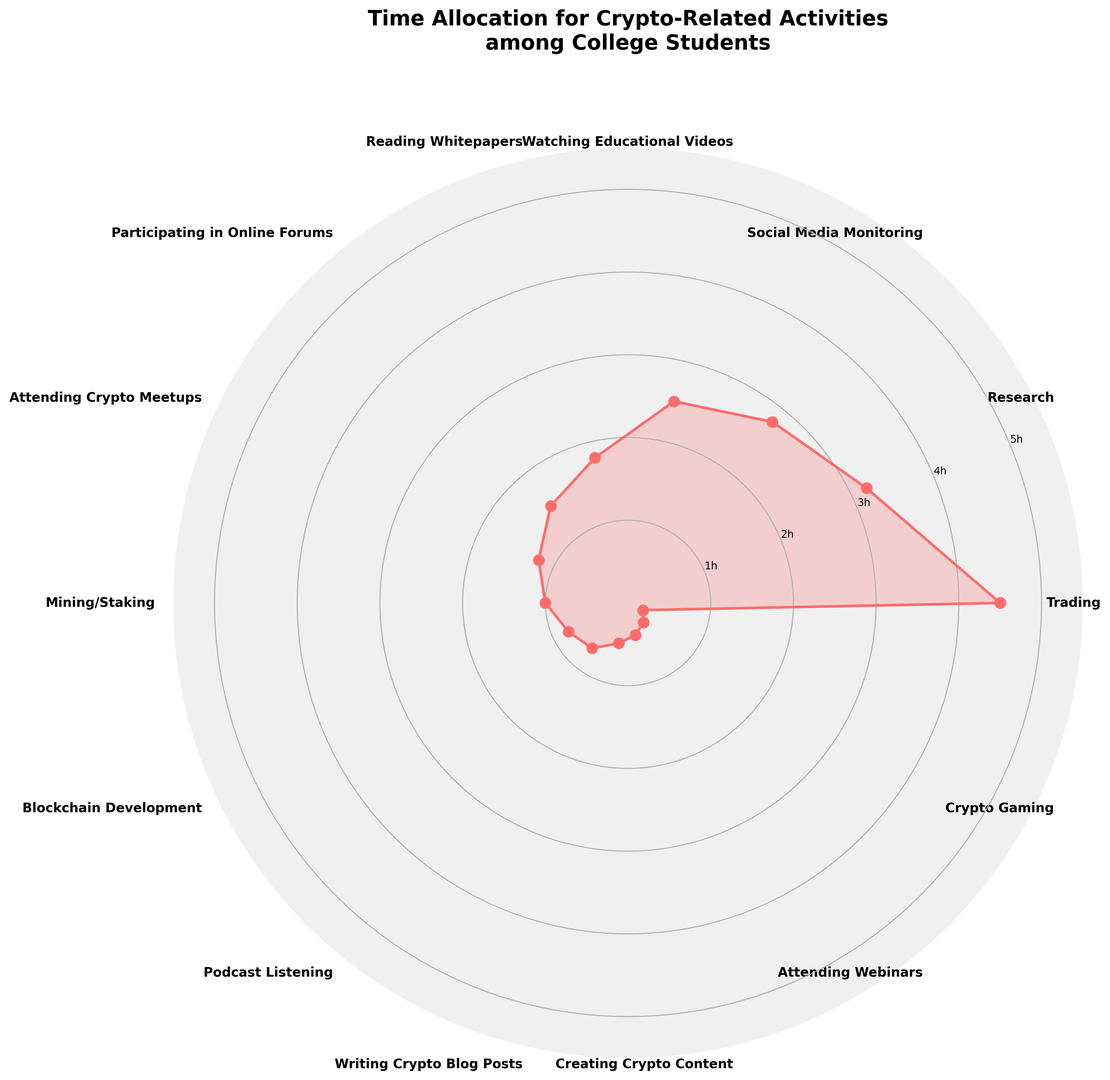What activity do college students spend the most hours on? By looking at the outermost data point on the rose chart, we observe that the activity 'Trading' peaks at 4.5 hours, which is the highest among all activities.
Answer: Trading What is the difference in hours spent between 'Research' and 'Watching Educational Videos'? To find the difference, subtract the hours spent on 'Watching Educational Videos' (2.5) from the hours spent on 'Research' (3.2). The difference is 3.2 - 2.5 = 0.7 hours.
Answer: 0.7 hours How many hours in total do students spend on the top three activities? The top three activities by hours are 'Trading' (4.5), 'Research' (3.2), and 'Social Media Monitoring' (2.8). The total sum is 4.5 + 3.2 + 2.8 = 10.5 hours.
Answer: 10.5 hours Which activity has the least time allocation? By observing the innermost point on the rose chart, we see that 'Crypto Gaming' is at 0.2 hours, which is the lowest among all activities.
Answer: Crypto Gaming How does the time spent on 'Mining/Staking' compare to the time spent on 'Blockchain Development'? 'Mining/Staking' is allocated 1.0 hours, whereas 'Blockchain Development' is allocated 0.8 hours. Therefore, 'Mining/Staking' has 0.2 more hours.
Answer: Mining/Staking has 0.2 more hours Which activities have time allocations within the 1.0 to 1.5-hour range? The activities with time allocations between 1.0 and 1.5 hours are 'Participating in Online Forums' (1.5 hours), 'Attending Crypto Meetups' (1.2 hours), and 'Mining/Staking' (1.0 hours).
Answer: Participating in Online Forums, Attending Crypto Meetups, Mining/Staking Are there more activities with time allocations below 0.5 hours or above 2.5 hours? Activities below 0.5 hours are 'Podcast Listening' (0.7), 'Writing Crypto Blog Posts' (0.5), 'Creating Crypto Content' (0.4), 'Attending Webinars' (0.3), 'Crypto Gaming' (0.2). Counts to 5 activities. Activities above 2.5 hours are 'Trading' (4.5), 'Research' (3.2), 'Social Media Monitoring' (2.8). Counts to 3 activities.
Answer: More activities below 0.5 hours What is the average amount of time spent on 'Watching Educational Videos', 'Reading Whitepapers', and 'Podcast Listening'? Sum the hours spent on these activities: 2.5 ('Watching Educational Videos') + 1.8 ('Reading Whitepapers') + 0.7 ('Podcast Listening'). The total is 2.5 + 1.8 + 0.7 = 5.0 hours. The average is 5.0 / 3 = 1.67 hours.
Answer: 1.67 hours Which activity has a time allocation closest to the median of all given activities? List the hours in ascending order: 0.2, 0.3, 0.4, 0.5, 0.7, 0.8, 1, 1.2, 1.5, 1.8, 2.5, 2.8, 3.2, 4.5. The median (middle value) is between 1 and 1.2. The closest activity is 'Mining/Staking' at 1.0 hours.
Answer: Mining/Staking 